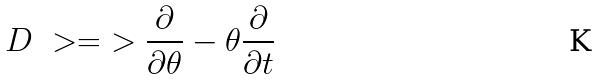Convert formula to latex. <formula><loc_0><loc_0><loc_500><loc_500>D \ > = \ > \frac { \partial } { \partial \theta } - \theta \frac { \partial } { \partial t }</formula> 